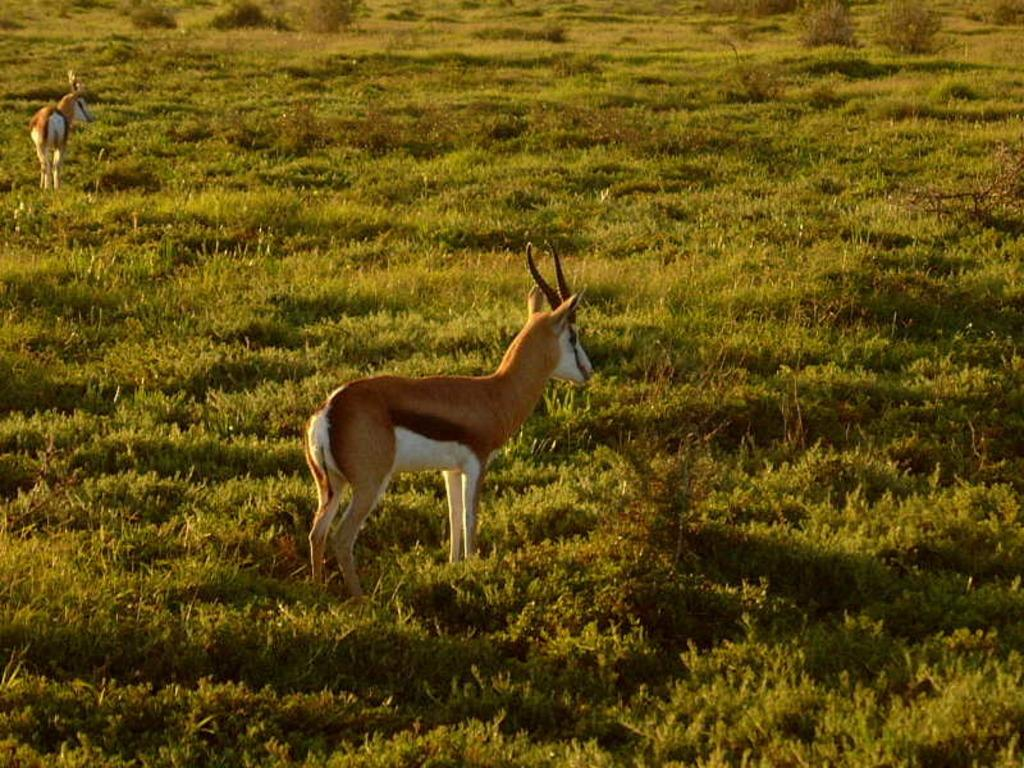What animals can be seen in the image? There are two deer in the image. What is the position of the deer in the image? The deer are standing on the ground. What type of vegetation is visible on the ground? There is grass and plants visible on the ground. What colors are the deer in the image? The deer are in brown and white color. Can you hear the deer whistling in the image? There is no sound in the image, so it is not possible to determine if the deer are whistling or not. 